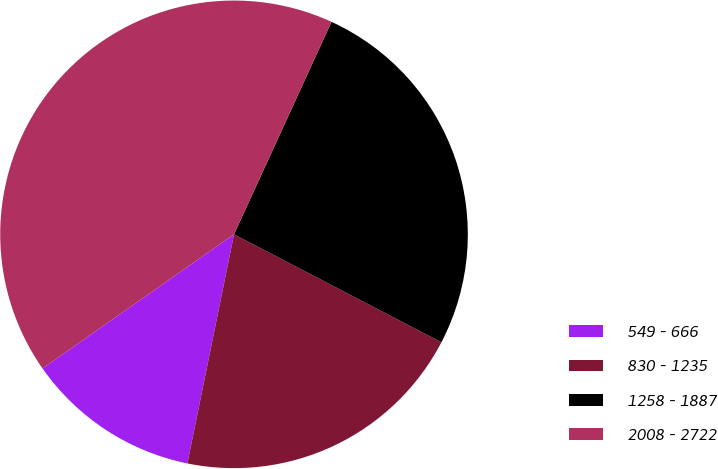<chart> <loc_0><loc_0><loc_500><loc_500><pie_chart><fcel>549 - 666<fcel>830 - 1235<fcel>1258 - 1887<fcel>2008 - 2722<nl><fcel>12.08%<fcel>20.56%<fcel>25.79%<fcel>41.57%<nl></chart> 